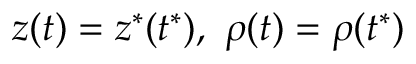Convert formula to latex. <formula><loc_0><loc_0><loc_500><loc_500>z ( t ) = z ^ { * } ( t ^ { * } ) , \ \rho ( t ) = \rho ( t ^ { * } )</formula> 